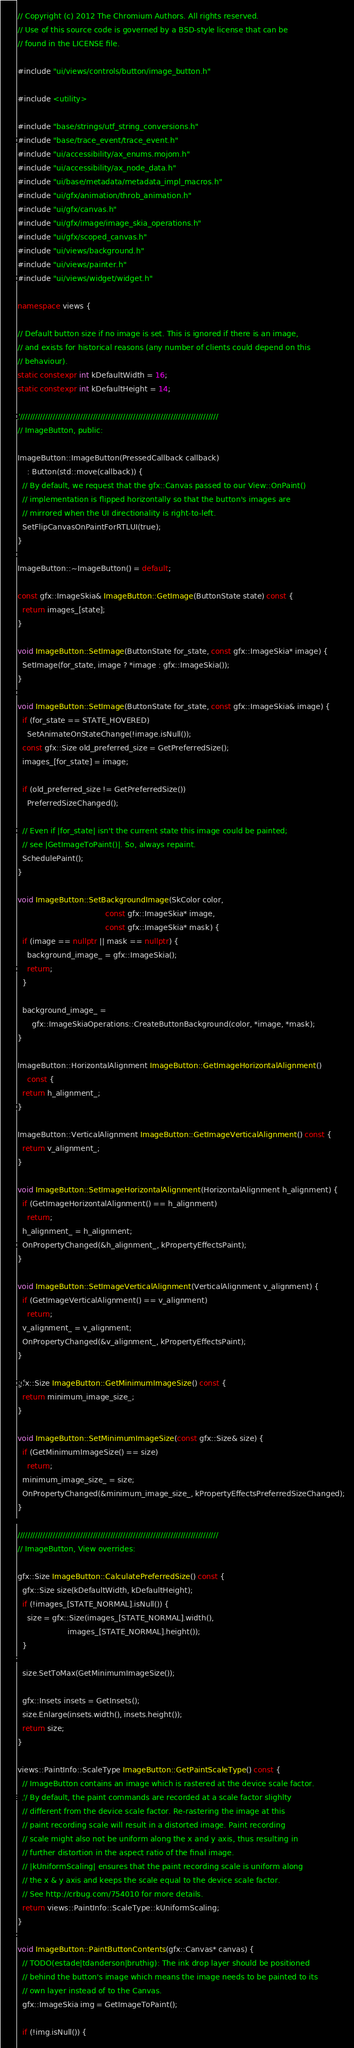<code> <loc_0><loc_0><loc_500><loc_500><_C++_>// Copyright (c) 2012 The Chromium Authors. All rights reserved.
// Use of this source code is governed by a BSD-style license that can be
// found in the LICENSE file.

#include "ui/views/controls/button/image_button.h"

#include <utility>

#include "base/strings/utf_string_conversions.h"
#include "base/trace_event/trace_event.h"
#include "ui/accessibility/ax_enums.mojom.h"
#include "ui/accessibility/ax_node_data.h"
#include "ui/base/metadata/metadata_impl_macros.h"
#include "ui/gfx/animation/throb_animation.h"
#include "ui/gfx/canvas.h"
#include "ui/gfx/image/image_skia_operations.h"
#include "ui/gfx/scoped_canvas.h"
#include "ui/views/background.h"
#include "ui/views/painter.h"
#include "ui/views/widget/widget.h"

namespace views {

// Default button size if no image is set. This is ignored if there is an image,
// and exists for historical reasons (any number of clients could depend on this
// behaviour).
static constexpr int kDefaultWidth = 16;
static constexpr int kDefaultHeight = 14;

////////////////////////////////////////////////////////////////////////////////
// ImageButton, public:

ImageButton::ImageButton(PressedCallback callback)
    : Button(std::move(callback)) {
  // By default, we request that the gfx::Canvas passed to our View::OnPaint()
  // implementation is flipped horizontally so that the button's images are
  // mirrored when the UI directionality is right-to-left.
  SetFlipCanvasOnPaintForRTLUI(true);
}

ImageButton::~ImageButton() = default;

const gfx::ImageSkia& ImageButton::GetImage(ButtonState state) const {
  return images_[state];
}

void ImageButton::SetImage(ButtonState for_state, const gfx::ImageSkia* image) {
  SetImage(for_state, image ? *image : gfx::ImageSkia());
}

void ImageButton::SetImage(ButtonState for_state, const gfx::ImageSkia& image) {
  if (for_state == STATE_HOVERED)
    SetAnimateOnStateChange(!image.isNull());
  const gfx::Size old_preferred_size = GetPreferredSize();
  images_[for_state] = image;

  if (old_preferred_size != GetPreferredSize())
    PreferredSizeChanged();

  // Even if |for_state| isn't the current state this image could be painted;
  // see |GetImageToPaint()|. So, always repaint.
  SchedulePaint();
}

void ImageButton::SetBackgroundImage(SkColor color,
                                     const gfx::ImageSkia* image,
                                     const gfx::ImageSkia* mask) {
  if (image == nullptr || mask == nullptr) {
    background_image_ = gfx::ImageSkia();
    return;
  }

  background_image_ =
      gfx::ImageSkiaOperations::CreateButtonBackground(color, *image, *mask);
}

ImageButton::HorizontalAlignment ImageButton::GetImageHorizontalAlignment()
    const {
  return h_alignment_;
}

ImageButton::VerticalAlignment ImageButton::GetImageVerticalAlignment() const {
  return v_alignment_;
}

void ImageButton::SetImageHorizontalAlignment(HorizontalAlignment h_alignment) {
  if (GetImageHorizontalAlignment() == h_alignment)
    return;
  h_alignment_ = h_alignment;
  OnPropertyChanged(&h_alignment_, kPropertyEffectsPaint);
}

void ImageButton::SetImageVerticalAlignment(VerticalAlignment v_alignment) {
  if (GetImageVerticalAlignment() == v_alignment)
    return;
  v_alignment_ = v_alignment;
  OnPropertyChanged(&v_alignment_, kPropertyEffectsPaint);
}

gfx::Size ImageButton::GetMinimumImageSize() const {
  return minimum_image_size_;
}

void ImageButton::SetMinimumImageSize(const gfx::Size& size) {
  if (GetMinimumImageSize() == size)
    return;
  minimum_image_size_ = size;
  OnPropertyChanged(&minimum_image_size_, kPropertyEffectsPreferredSizeChanged);
}

////////////////////////////////////////////////////////////////////////////////
// ImageButton, View overrides:

gfx::Size ImageButton::CalculatePreferredSize() const {
  gfx::Size size(kDefaultWidth, kDefaultHeight);
  if (!images_[STATE_NORMAL].isNull()) {
    size = gfx::Size(images_[STATE_NORMAL].width(),
                     images_[STATE_NORMAL].height());
  }

  size.SetToMax(GetMinimumImageSize());

  gfx::Insets insets = GetInsets();
  size.Enlarge(insets.width(), insets.height());
  return size;
}

views::PaintInfo::ScaleType ImageButton::GetPaintScaleType() const {
  // ImageButton contains an image which is rastered at the device scale factor.
  // By default, the paint commands are recorded at a scale factor slighlty
  // different from the device scale factor. Re-rastering the image at this
  // paint recording scale will result in a distorted image. Paint recording
  // scale might also not be uniform along the x and y axis, thus resulting in
  // further distortion in the aspect ratio of the final image.
  // |kUniformScaling| ensures that the paint recording scale is uniform along
  // the x & y axis and keeps the scale equal to the device scale factor.
  // See http://crbug.com/754010 for more details.
  return views::PaintInfo::ScaleType::kUniformScaling;
}

void ImageButton::PaintButtonContents(gfx::Canvas* canvas) {
  // TODO(estade|tdanderson|bruthig): The ink drop layer should be positioned
  // behind the button's image which means the image needs to be painted to its
  // own layer instead of to the Canvas.
  gfx::ImageSkia img = GetImageToPaint();

  if (!img.isNull()) {</code> 